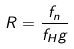<formula> <loc_0><loc_0><loc_500><loc_500>R = \frac { f _ { n } } { f _ { H } g }</formula> 